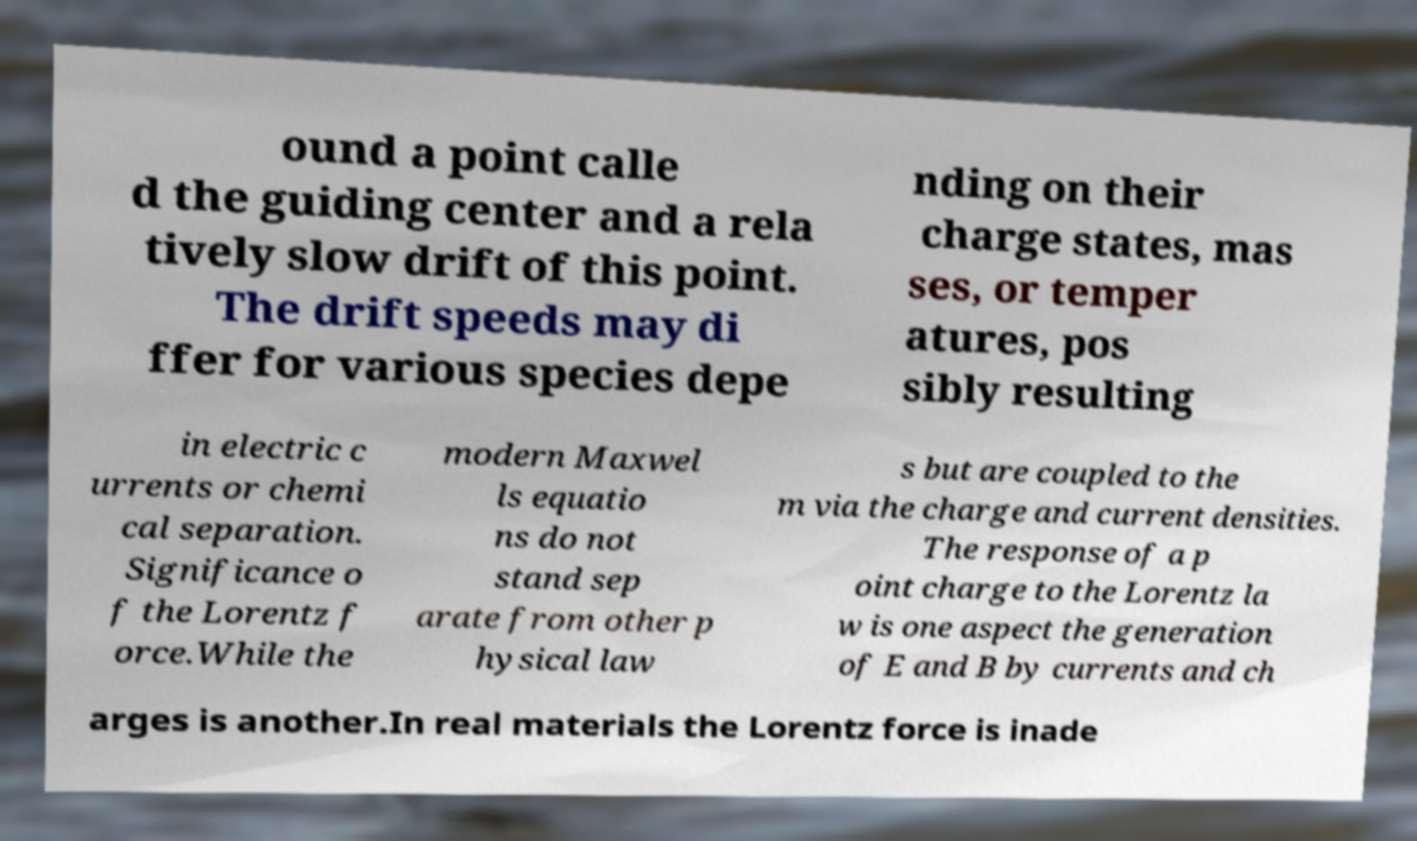For documentation purposes, I need the text within this image transcribed. Could you provide that? ound a point calle d the guiding center and a rela tively slow drift of this point. The drift speeds may di ffer for various species depe nding on their charge states, mas ses, or temper atures, pos sibly resulting in electric c urrents or chemi cal separation. Significance o f the Lorentz f orce.While the modern Maxwel ls equatio ns do not stand sep arate from other p hysical law s but are coupled to the m via the charge and current densities. The response of a p oint charge to the Lorentz la w is one aspect the generation of E and B by currents and ch arges is another.In real materials the Lorentz force is inade 